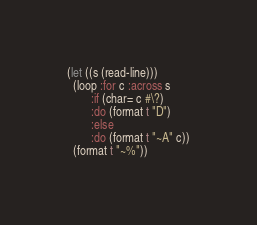Convert code to text. <code><loc_0><loc_0><loc_500><loc_500><_Lisp_>(let ((s (read-line)))
  (loop :for c :across s
        :if (char= c #\?)
        :do (format t "D")
        :else
        :do (format t "~A" c))
  (format t "~%"))

</code> 